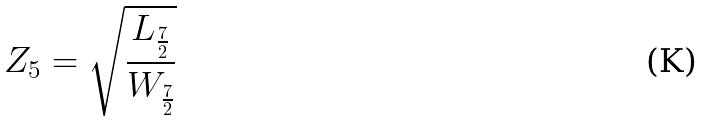<formula> <loc_0><loc_0><loc_500><loc_500>Z _ { 5 } = \sqrt { \frac { L _ { \frac { 7 } { 2 } } } { W _ { \frac { 7 } { 2 } } } }</formula> 